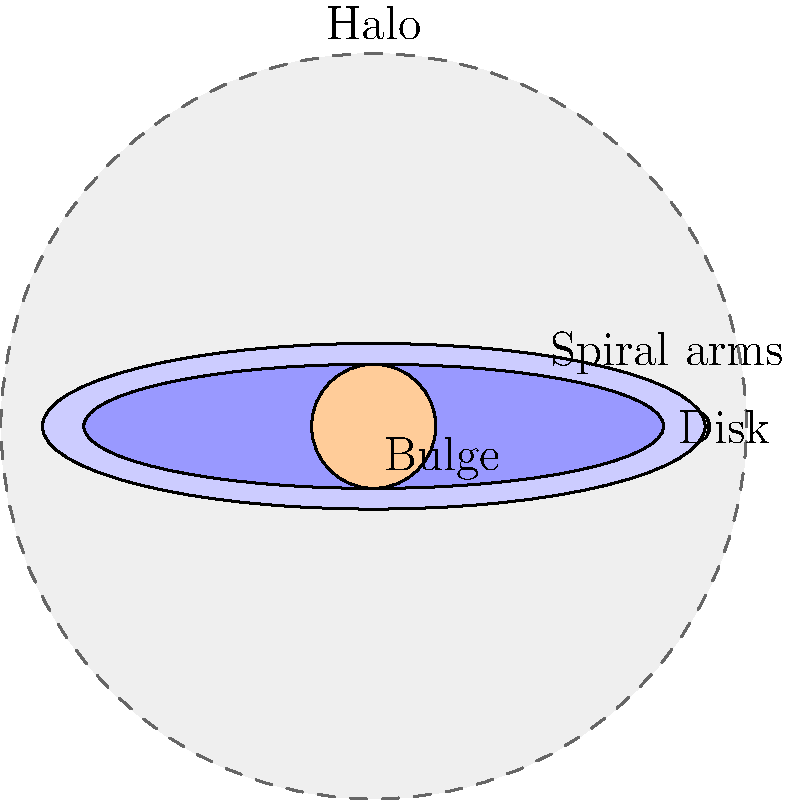In the context of secure communication systems for law enforcement, understanding the structure of complex systems is crucial. Similarly, in astronomy, galaxies have complex structures. Based on the diagram, which component of a spiral galaxy contains the oldest stars and extends furthest from the galactic center, potentially serving as an analogy for the outermost layer of a multi-layered security system? To answer this question, let's analyze the structure of a spiral galaxy as shown in the diagram:

1. The diagram shows four main components of a spiral galaxy:
   a) Bulge: The central, roughly spherical region
   b) Disk: The flat, circular region containing the spiral arms
   c) Halo: The outermost, spherical region surrounding the entire galaxy
   d) Spiral arms: The curved structures within the disk

2. The halo is the outermost component of the galaxy, extending beyond the visible disk and bulge.

3. The halo is composed primarily of old stars and globular clusters, which are some of the oldest objects in the galaxy.

4. In terms of galactic evolution, the halo formed early in the galaxy's history, making it home to the oldest stellar populations.

5. The halo's extensive reach and age make it analogous to the outermost layer of a multi-layered security system, which often encompasses older, well-established security measures that provide broad protection.

Therefore, the component that contains the oldest stars and extends furthest from the galactic center is the halo.
Answer: Halo 